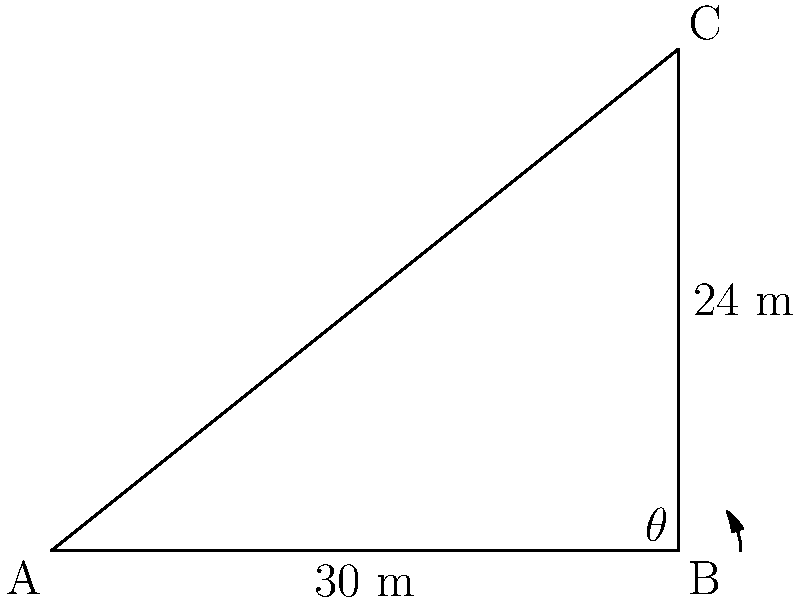You are studying insect populations on two adjacent rooftop gardens. The first building (A) is 30 meters away from the second building (B), which is 24 meters taller. What is the direct distance between the two rooftop gardens, and what is the angle of elevation from the first rooftop to the second? Round your answers to the nearest tenth. Let's approach this step-by-step:

1) We can treat this as a right-angled triangle problem. Let's call the direct distance between the rooftops c.

2) We know the base of the triangle (adjacent side) is 30 m, and the height (opposite side) is 24 m.

3) To find the direct distance c (hypotenuse), we can use the Pythagorean theorem:

   $$c^2 = 30^2 + 24^2$$
   $$c^2 = 900 + 576 = 1476$$
   $$c = \sqrt{1476} \approx 38.4$$

4) So the direct distance between the rooftops is approximately 38.4 meters.

5) For the angle of elevation $\theta$, we can use the tangent function:

   $$\tan(\theta) = \frac{\text{opposite}}{\text{adjacent}} = \frac{24}{30} = 0.8$$

6) To get $\theta$, we take the inverse tangent (arctangent):

   $$\theta = \tan^{-1}(0.8) \approx 38.7°$$

Therefore, the direct distance is approximately 38.4 meters, and the angle of elevation is about 38.7°.
Answer: 38.4 m, 38.7° 